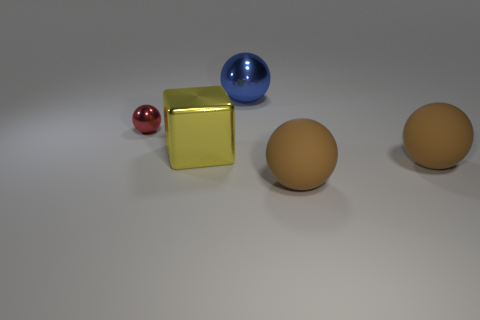How many brown spheres must be subtracted to get 1 brown spheres? 1 Subtract all red spheres. How many spheres are left? 3 Subtract all balls. How many objects are left? 1 Subtract 3 spheres. How many spheres are left? 1 Subtract all yellow spheres. Subtract all yellow cylinders. How many spheres are left? 4 Subtract all purple spheres. How many brown cubes are left? 0 Subtract all large purple rubber objects. Subtract all big yellow metallic blocks. How many objects are left? 4 Add 5 brown rubber spheres. How many brown rubber spheres are left? 7 Add 1 large yellow shiny cubes. How many large yellow shiny cubes exist? 2 Add 1 big brown things. How many objects exist? 6 